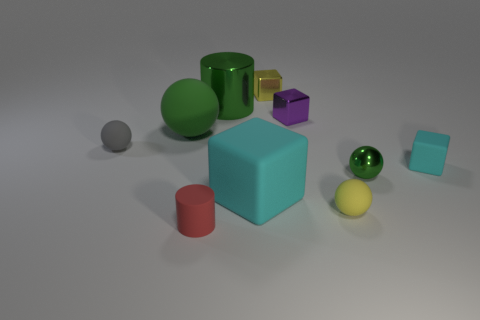Among the objects, which one looks the most reflective? The most reflective object appears to be the green, spherical ball due to its shiny surface and clear reflections. 